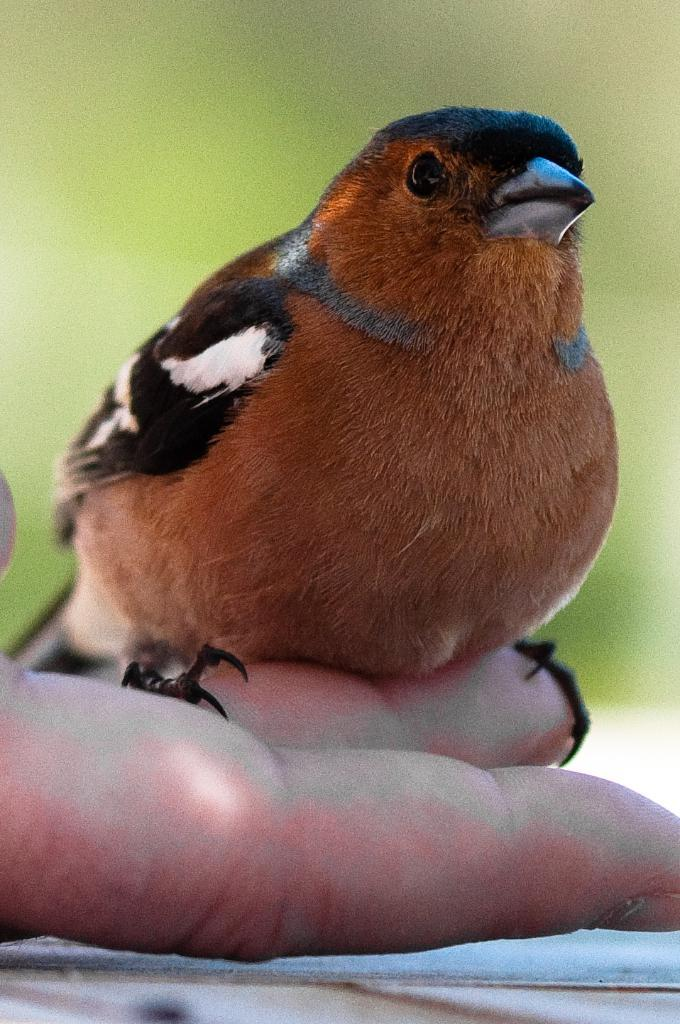What type of animal is in the image? There is a bird in the image. Can you describe the bird's coloring? The bird has brown, black, and white coloring. How is the bird interacting with a person in the image? The bird is on a person's fingers. What can be observed about the background of the image? The background of the image is blurred, and the background color is green. What type of horn is visible on the bird's head in the image? There is no horn visible on the bird's head in the image. What is the bird's current health condition in the image? The image does not provide any information about the bird's health condition. 